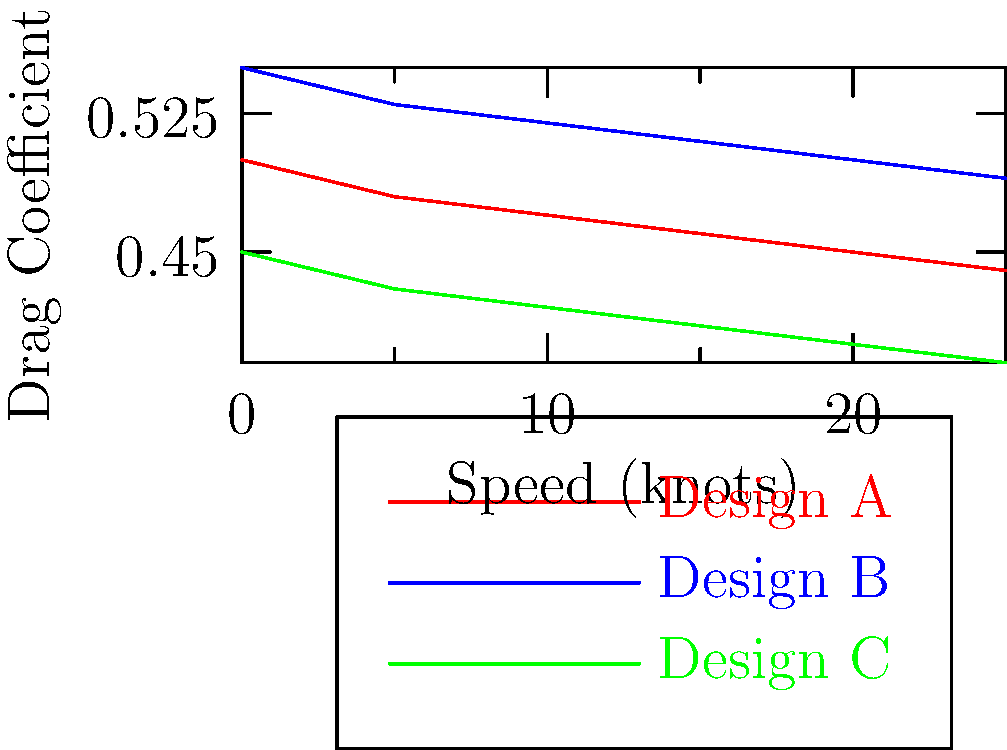As a maritime shipping executive, you're evaluating three ship designs (A, B, and C) based on their drag coefficients at various speeds. Using the graph provided, which design would you recommend for a route that typically operates at 20 knots to maximize fuel efficiency and maintain competitive shipping rates? To determine the most fuel-efficient design at 20 knots, we need to analyze the drag coefficients of each design at that speed:

1. Understand the relationship: Lower drag coefficient correlates with higher fuel efficiency.

2. Locate the 20-knot mark on the x-axis.

3. Compare the drag coefficients at 20 knots:
   - Design A (red): Approximately 0.45
   - Design B (blue): Approximately 0.50
   - Design C (green): Approximately 0.40

4. Rank the designs from lowest to highest drag coefficient:
   C < A < B

5. Interpret the results:
   - Design C has the lowest drag coefficient at 20 knots, indicating the highest fuel efficiency.
   - Design A is the second most efficient.
   - Design B is the least efficient of the three at 20 knots.

6. Consider the business implications:
   - Higher fuel efficiency leads to lower operating costs.
   - Lower costs allow for more competitive shipping rates.

Therefore, Design C would be the most suitable choice for a route operating at 20 knots, as it offers the best fuel efficiency and potential for competitive pricing.
Answer: Design C 